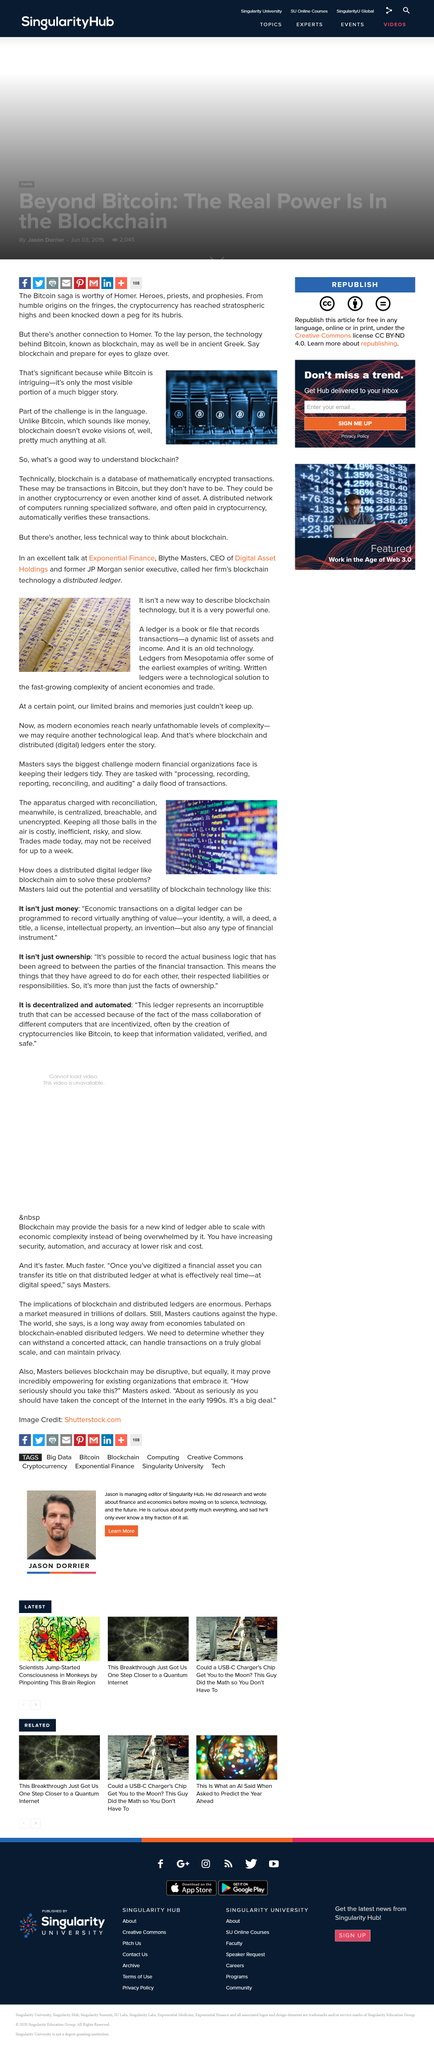Specify some key components in this picture. Ledgers from Mesopotamia contain some of the earliest examples of writing, which date back thousands of years. The apparatus used for reconciliation are charged centrally, as confirmed by the answer. Digital ledgers can record any form of economic value. The author believes that Bitcoin's story is worthy of Homer, yes it is. A ledger is a book or file that records transactions, such as purchases or sales, in a business. 